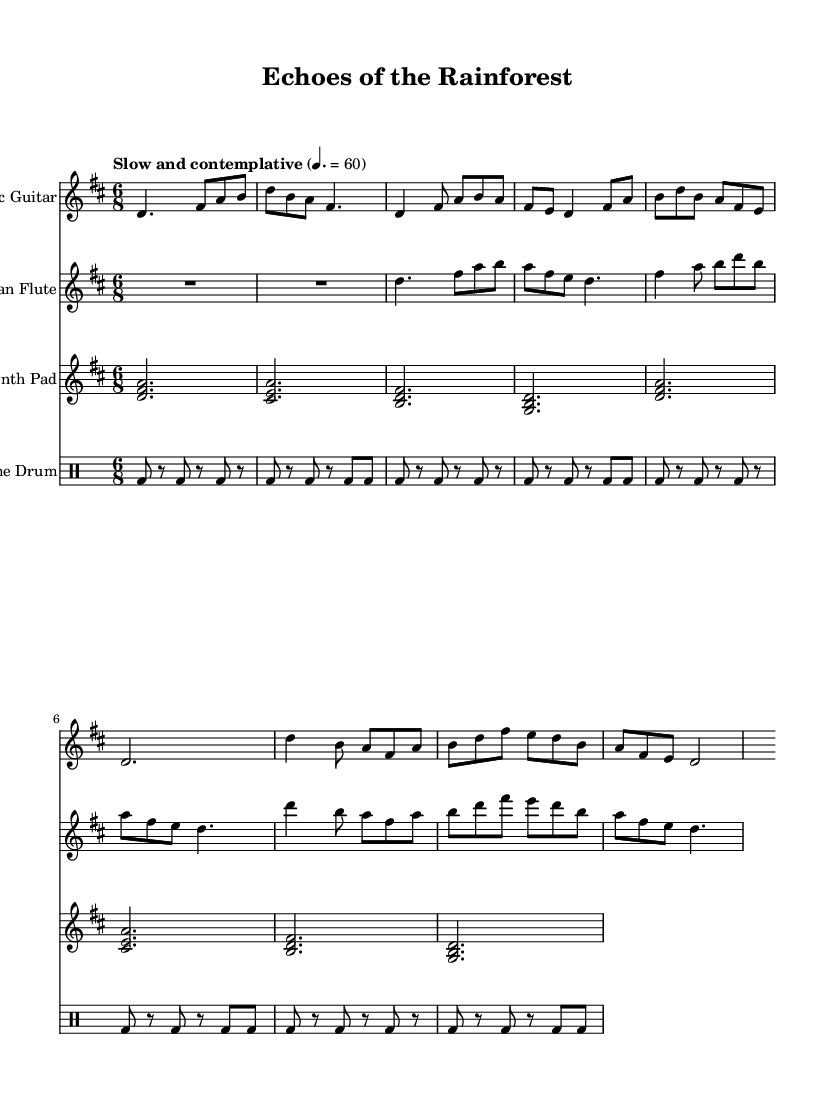What is the key signature of this music? The key signature is D major, which has two sharps (F# and C#).
Answer: D major What is the time signature of this piece? The time signature is 6/8, indicating six eighth notes per measure.
Answer: 6/8 What is the tempo marking given for this piece? The tempo marking indicates "Slow and contemplative" at a quarter note equals 60 beats per minute.
Answer: Slow and contemplative Which instrument leads the melody in this composition? The Acoustic Guitar plays the primary melodic material, establishing the piece's thematic content.
Answer: Acoustic Guitar How many different instruments are featured in this score? There are four different instruments in the score: Acoustic Guitar, Native American Flute, Synth Pad, and Frame Drum.
Answer: Four What type of rhythm is predominantly used in the Frame Drum part? The Frame Drum primarily employs a steady beat with eighth notes and rests, creating a repetitive rhythmic pattern.
Answer: Steady beat What combination of elements characterizes the Fusion genre depicted in this piece? The Fusion is characterized by the blending of folk melodies (from the acoustic guitar and flute) with electronic sounds (from the synth pad) and traditional percussion (frame drum), evoking a serene atmosphere that reflects endangered ecosystems.
Answer: Blending of folk and electronic elements 